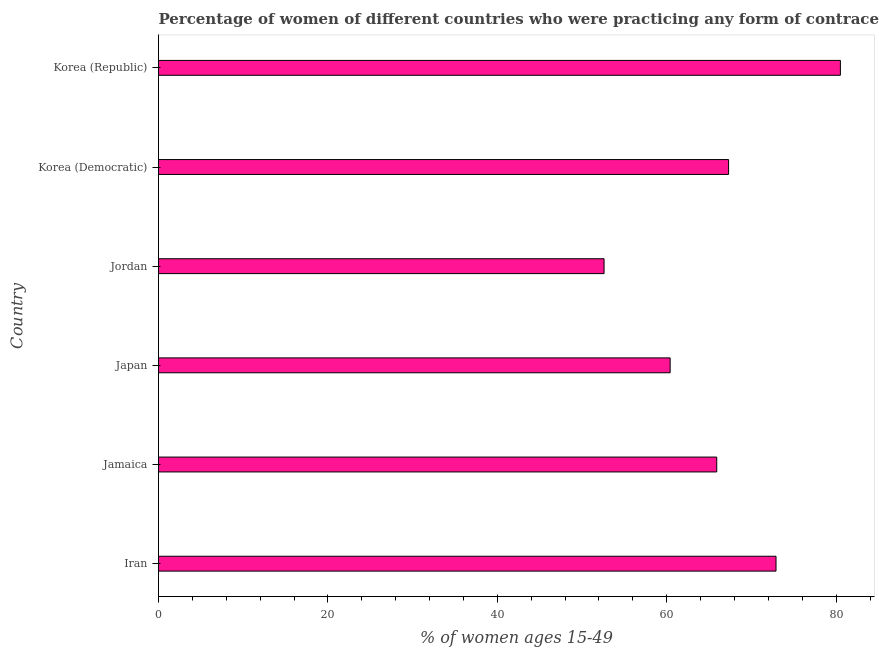Does the graph contain any zero values?
Your answer should be compact. No. What is the title of the graph?
Your answer should be compact. Percentage of women of different countries who were practicing any form of contraception in 1997. What is the label or title of the X-axis?
Offer a terse response. % of women ages 15-49. What is the label or title of the Y-axis?
Your response must be concise. Country. What is the contraceptive prevalence in Korea (Democratic)?
Ensure brevity in your answer.  67.3. Across all countries, what is the maximum contraceptive prevalence?
Keep it short and to the point. 80.5. Across all countries, what is the minimum contraceptive prevalence?
Your answer should be very brief. 52.6. In which country was the contraceptive prevalence maximum?
Provide a succinct answer. Korea (Republic). In which country was the contraceptive prevalence minimum?
Your answer should be very brief. Jordan. What is the sum of the contraceptive prevalence?
Provide a short and direct response. 399.6. What is the difference between the contraceptive prevalence in Iran and Jordan?
Offer a terse response. 20.3. What is the average contraceptive prevalence per country?
Your answer should be compact. 66.6. What is the median contraceptive prevalence?
Give a very brief answer. 66.6. In how many countries, is the contraceptive prevalence greater than 8 %?
Your response must be concise. 6. What is the ratio of the contraceptive prevalence in Iran to that in Korea (Democratic)?
Ensure brevity in your answer.  1.08. Is the difference between the contraceptive prevalence in Japan and Jordan greater than the difference between any two countries?
Provide a succinct answer. No. What is the difference between the highest and the lowest contraceptive prevalence?
Your answer should be very brief. 27.9. In how many countries, is the contraceptive prevalence greater than the average contraceptive prevalence taken over all countries?
Give a very brief answer. 3. How many bars are there?
Offer a terse response. 6. Are all the bars in the graph horizontal?
Your answer should be very brief. Yes. What is the difference between two consecutive major ticks on the X-axis?
Make the answer very short. 20. Are the values on the major ticks of X-axis written in scientific E-notation?
Provide a succinct answer. No. What is the % of women ages 15-49 in Iran?
Offer a very short reply. 72.9. What is the % of women ages 15-49 of Jamaica?
Offer a very short reply. 65.9. What is the % of women ages 15-49 of Japan?
Your answer should be compact. 60.4. What is the % of women ages 15-49 of Jordan?
Provide a short and direct response. 52.6. What is the % of women ages 15-49 in Korea (Democratic)?
Provide a succinct answer. 67.3. What is the % of women ages 15-49 of Korea (Republic)?
Offer a terse response. 80.5. What is the difference between the % of women ages 15-49 in Iran and Japan?
Offer a terse response. 12.5. What is the difference between the % of women ages 15-49 in Iran and Jordan?
Ensure brevity in your answer.  20.3. What is the difference between the % of women ages 15-49 in Iran and Korea (Democratic)?
Keep it short and to the point. 5.6. What is the difference between the % of women ages 15-49 in Iran and Korea (Republic)?
Your answer should be compact. -7.6. What is the difference between the % of women ages 15-49 in Jamaica and Korea (Democratic)?
Ensure brevity in your answer.  -1.4. What is the difference between the % of women ages 15-49 in Jamaica and Korea (Republic)?
Your answer should be compact. -14.6. What is the difference between the % of women ages 15-49 in Japan and Jordan?
Make the answer very short. 7.8. What is the difference between the % of women ages 15-49 in Japan and Korea (Republic)?
Your answer should be compact. -20.1. What is the difference between the % of women ages 15-49 in Jordan and Korea (Democratic)?
Provide a succinct answer. -14.7. What is the difference between the % of women ages 15-49 in Jordan and Korea (Republic)?
Your answer should be compact. -27.9. What is the ratio of the % of women ages 15-49 in Iran to that in Jamaica?
Make the answer very short. 1.11. What is the ratio of the % of women ages 15-49 in Iran to that in Japan?
Offer a terse response. 1.21. What is the ratio of the % of women ages 15-49 in Iran to that in Jordan?
Provide a short and direct response. 1.39. What is the ratio of the % of women ages 15-49 in Iran to that in Korea (Democratic)?
Your answer should be very brief. 1.08. What is the ratio of the % of women ages 15-49 in Iran to that in Korea (Republic)?
Provide a short and direct response. 0.91. What is the ratio of the % of women ages 15-49 in Jamaica to that in Japan?
Make the answer very short. 1.09. What is the ratio of the % of women ages 15-49 in Jamaica to that in Jordan?
Offer a terse response. 1.25. What is the ratio of the % of women ages 15-49 in Jamaica to that in Korea (Democratic)?
Provide a succinct answer. 0.98. What is the ratio of the % of women ages 15-49 in Jamaica to that in Korea (Republic)?
Provide a short and direct response. 0.82. What is the ratio of the % of women ages 15-49 in Japan to that in Jordan?
Offer a very short reply. 1.15. What is the ratio of the % of women ages 15-49 in Japan to that in Korea (Democratic)?
Your response must be concise. 0.9. What is the ratio of the % of women ages 15-49 in Japan to that in Korea (Republic)?
Keep it short and to the point. 0.75. What is the ratio of the % of women ages 15-49 in Jordan to that in Korea (Democratic)?
Your answer should be compact. 0.78. What is the ratio of the % of women ages 15-49 in Jordan to that in Korea (Republic)?
Ensure brevity in your answer.  0.65. What is the ratio of the % of women ages 15-49 in Korea (Democratic) to that in Korea (Republic)?
Your answer should be compact. 0.84. 